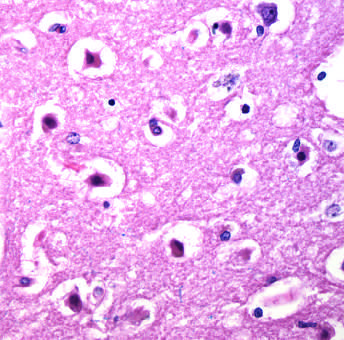re the cell bodies shrunken and eosinophilic?
Answer the question using a single word or phrase. Yes 